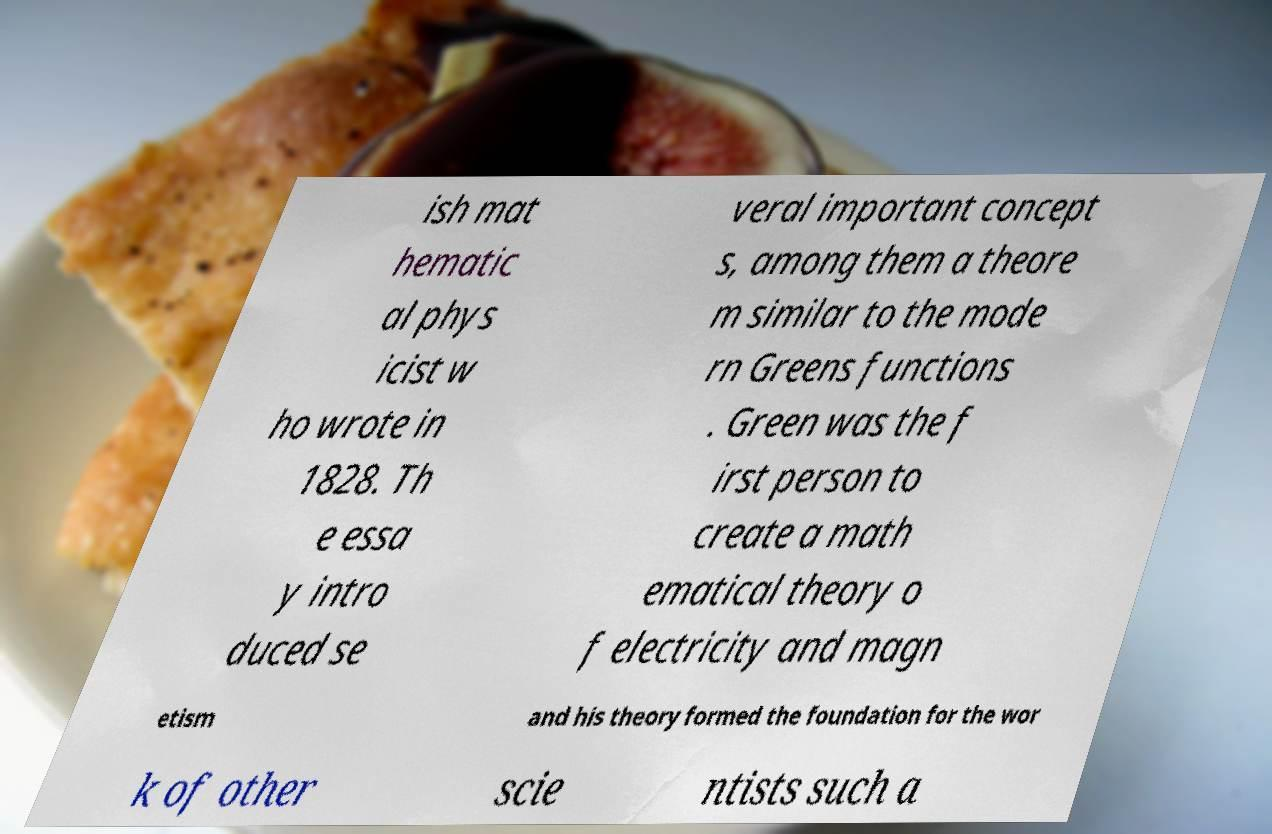Can you accurately transcribe the text from the provided image for me? ish mat hematic al phys icist w ho wrote in 1828. Th e essa y intro duced se veral important concept s, among them a theore m similar to the mode rn Greens functions . Green was the f irst person to create a math ematical theory o f electricity and magn etism and his theory formed the foundation for the wor k of other scie ntists such a 